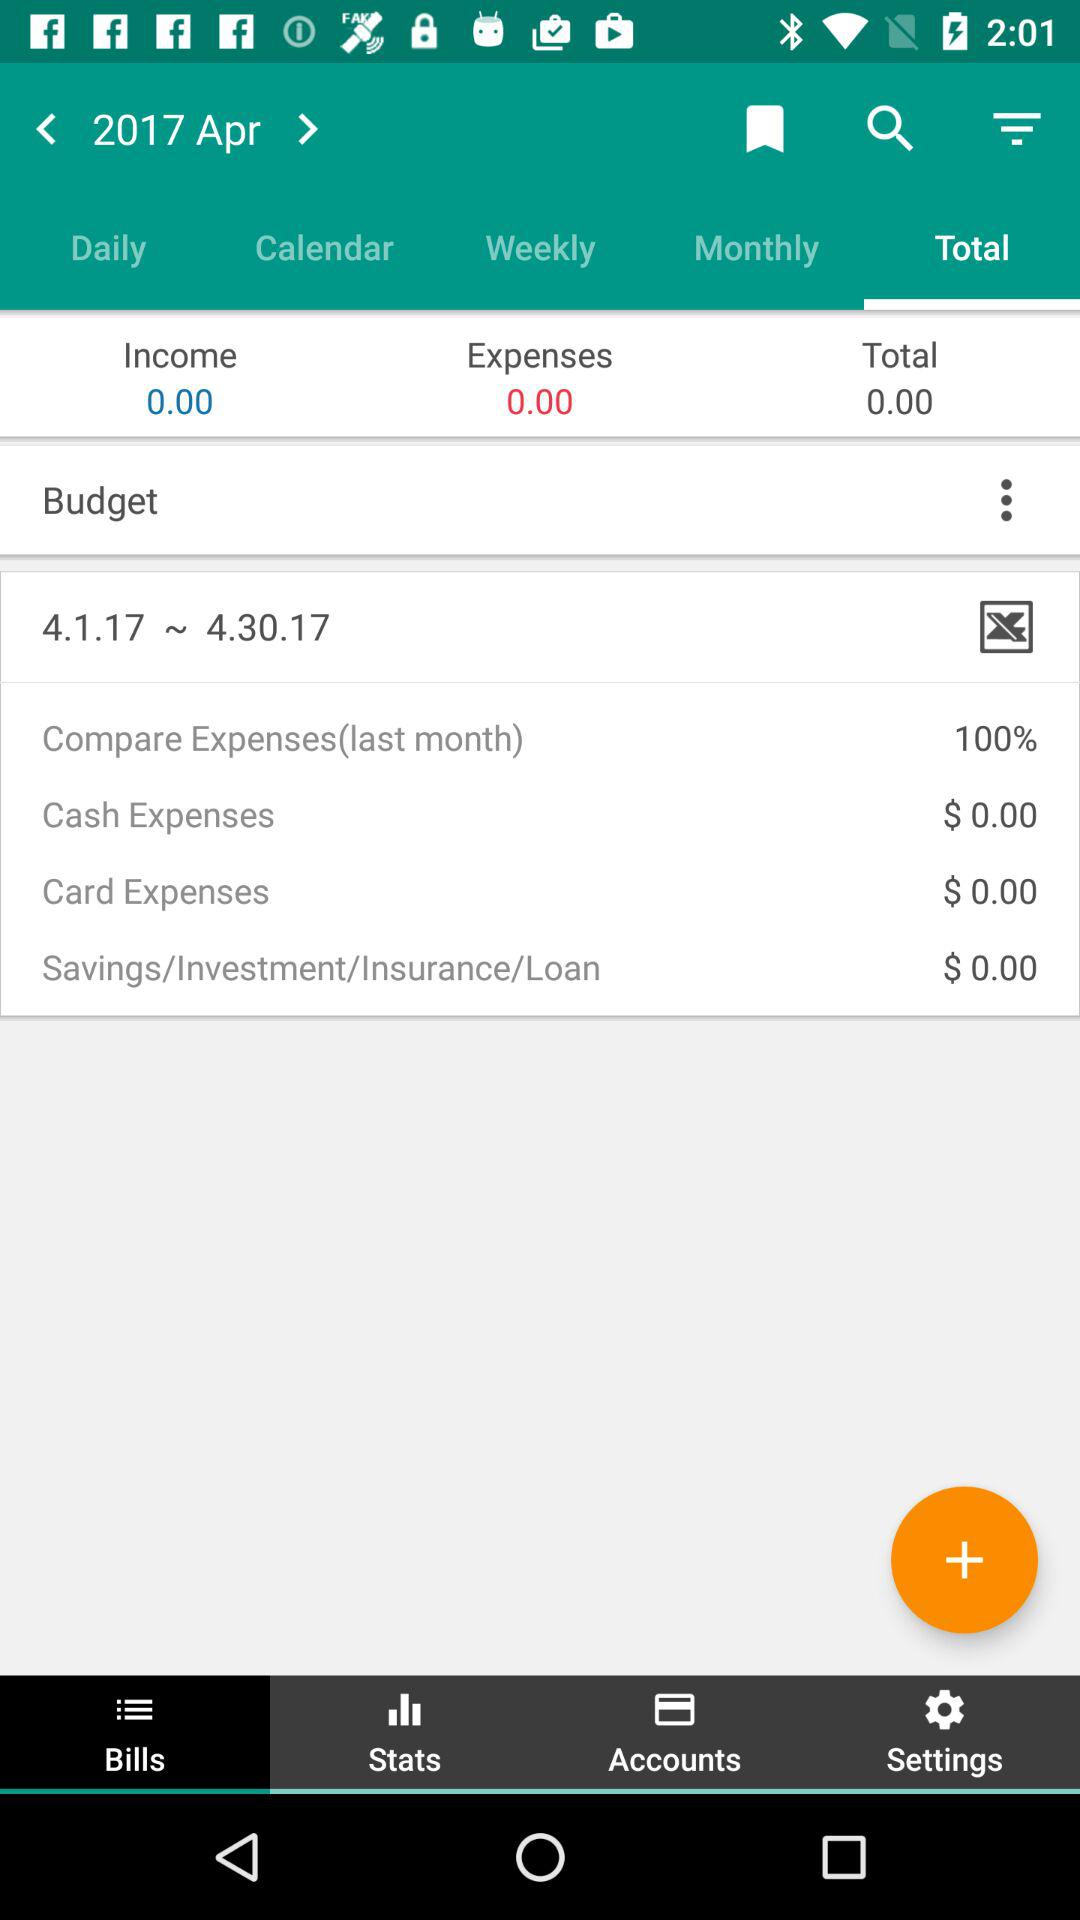How much are the cash expenses?
Answer the question using a single word or phrase. $0.00 